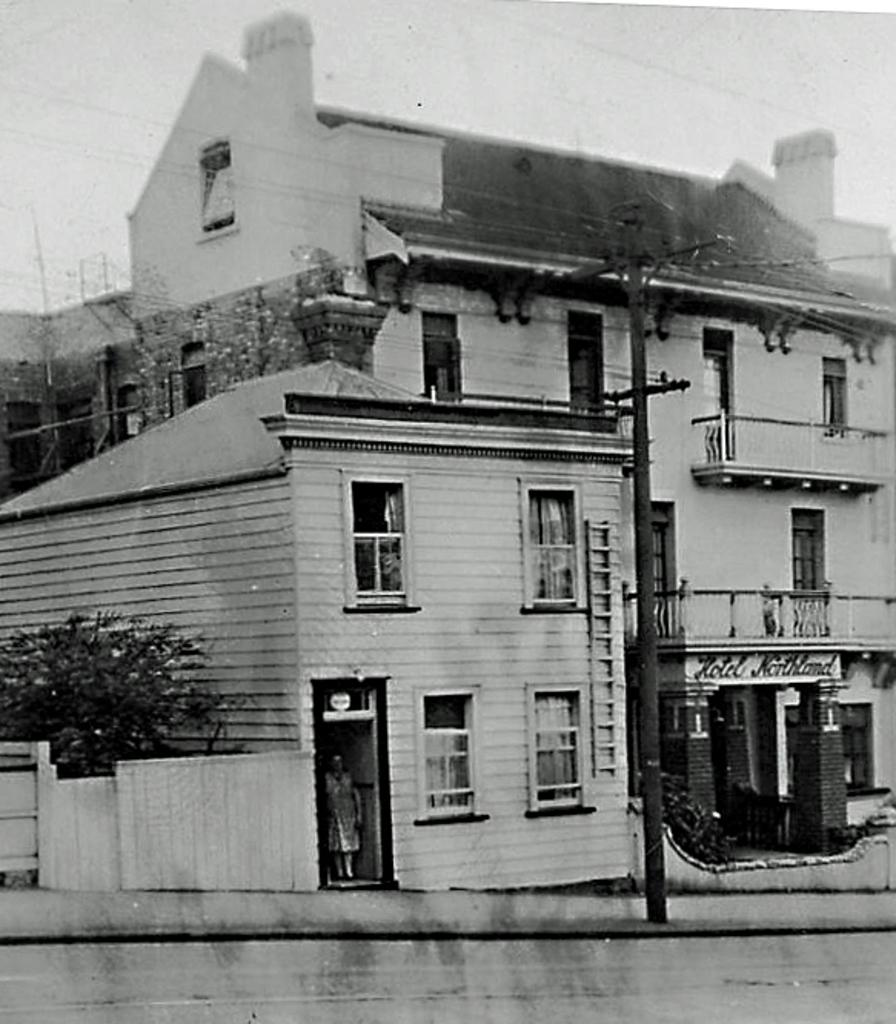What is the color scheme of the image? The image is black and white. What can be seen in the image besides the color scheme? There is a road, a person, a pole, a wall, trees, and buildings with windows in the image. What month is depicted in the image? The image does not depict a specific month; it is a black and white image with various elements. Can you tell me how many tanks are present in the image? There are no tanks present in the image. 